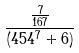<formula> <loc_0><loc_0><loc_500><loc_500>\frac { \frac { 7 } { 1 6 7 } } { ( 4 5 4 ^ { 7 } + 6 ) }</formula> 